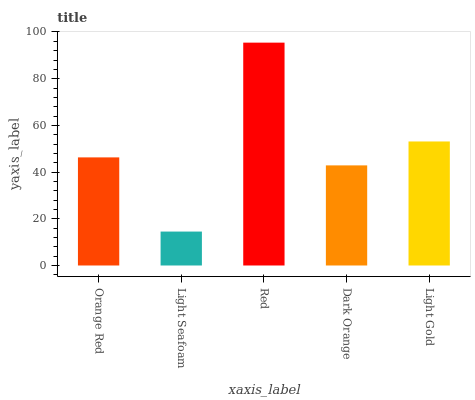Is Light Seafoam the minimum?
Answer yes or no. Yes. Is Red the maximum?
Answer yes or no. Yes. Is Red the minimum?
Answer yes or no. No. Is Light Seafoam the maximum?
Answer yes or no. No. Is Red greater than Light Seafoam?
Answer yes or no. Yes. Is Light Seafoam less than Red?
Answer yes or no. Yes. Is Light Seafoam greater than Red?
Answer yes or no. No. Is Red less than Light Seafoam?
Answer yes or no. No. Is Orange Red the high median?
Answer yes or no. Yes. Is Orange Red the low median?
Answer yes or no. Yes. Is Dark Orange the high median?
Answer yes or no. No. Is Light Gold the low median?
Answer yes or no. No. 